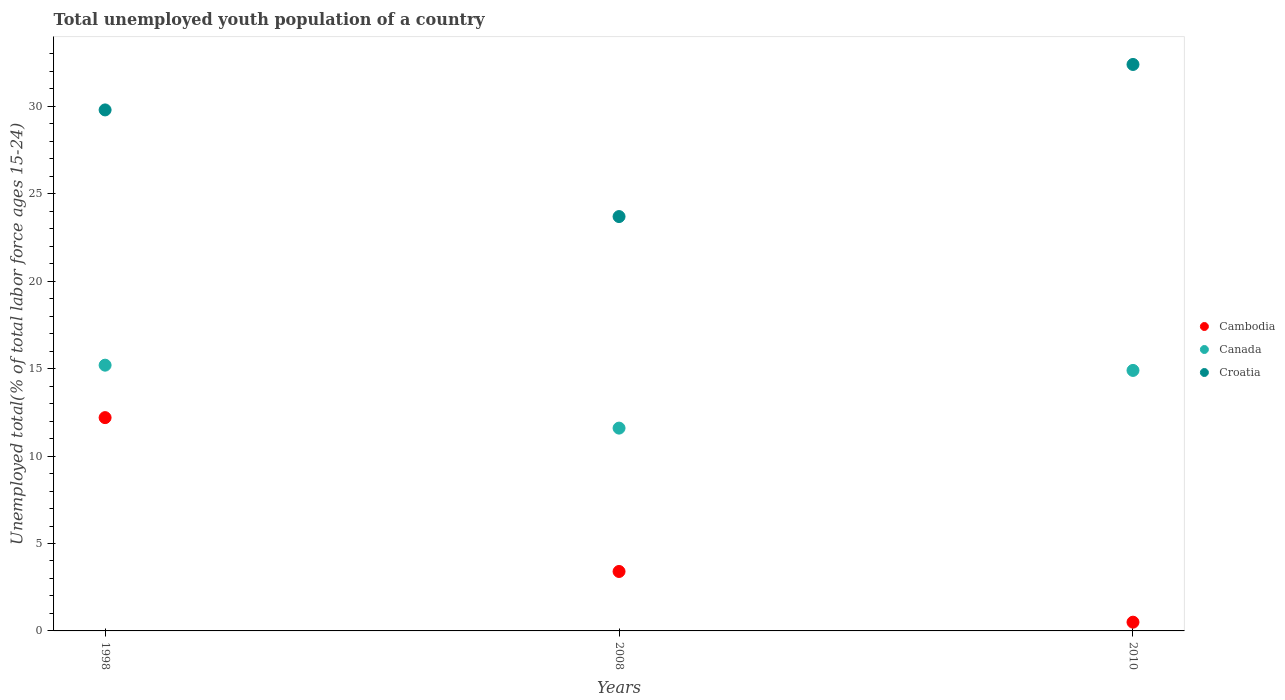Is the number of dotlines equal to the number of legend labels?
Provide a succinct answer. Yes. What is the percentage of total unemployed youth population of a country in Canada in 2008?
Keep it short and to the point. 11.6. Across all years, what is the maximum percentage of total unemployed youth population of a country in Cambodia?
Provide a short and direct response. 12.2. Across all years, what is the minimum percentage of total unemployed youth population of a country in Croatia?
Give a very brief answer. 23.7. What is the total percentage of total unemployed youth population of a country in Croatia in the graph?
Provide a succinct answer. 85.9. What is the difference between the percentage of total unemployed youth population of a country in Croatia in 1998 and that in 2008?
Your answer should be compact. 6.1. What is the difference between the percentage of total unemployed youth population of a country in Croatia in 1998 and the percentage of total unemployed youth population of a country in Cambodia in 2010?
Your response must be concise. 29.3. What is the average percentage of total unemployed youth population of a country in Cambodia per year?
Ensure brevity in your answer.  5.37. What is the ratio of the percentage of total unemployed youth population of a country in Croatia in 2008 to that in 2010?
Make the answer very short. 0.73. Is the percentage of total unemployed youth population of a country in Canada in 2008 less than that in 2010?
Your response must be concise. Yes. What is the difference between the highest and the second highest percentage of total unemployed youth population of a country in Canada?
Keep it short and to the point. 0.3. What is the difference between the highest and the lowest percentage of total unemployed youth population of a country in Cambodia?
Your answer should be compact. 11.7. Is the sum of the percentage of total unemployed youth population of a country in Croatia in 2008 and 2010 greater than the maximum percentage of total unemployed youth population of a country in Canada across all years?
Make the answer very short. Yes. Is it the case that in every year, the sum of the percentage of total unemployed youth population of a country in Canada and percentage of total unemployed youth population of a country in Cambodia  is greater than the percentage of total unemployed youth population of a country in Croatia?
Keep it short and to the point. No. Does the percentage of total unemployed youth population of a country in Cambodia monotonically increase over the years?
Offer a very short reply. No. Is the percentage of total unemployed youth population of a country in Cambodia strictly less than the percentage of total unemployed youth population of a country in Canada over the years?
Offer a terse response. Yes. How many dotlines are there?
Offer a terse response. 3. How many years are there in the graph?
Provide a short and direct response. 3. What is the difference between two consecutive major ticks on the Y-axis?
Ensure brevity in your answer.  5. Does the graph contain any zero values?
Offer a very short reply. No. What is the title of the graph?
Keep it short and to the point. Total unemployed youth population of a country. What is the label or title of the Y-axis?
Keep it short and to the point. Unemployed total(% of total labor force ages 15-24). What is the Unemployed total(% of total labor force ages 15-24) in Cambodia in 1998?
Ensure brevity in your answer.  12.2. What is the Unemployed total(% of total labor force ages 15-24) in Canada in 1998?
Your answer should be very brief. 15.2. What is the Unemployed total(% of total labor force ages 15-24) of Croatia in 1998?
Make the answer very short. 29.8. What is the Unemployed total(% of total labor force ages 15-24) in Cambodia in 2008?
Keep it short and to the point. 3.4. What is the Unemployed total(% of total labor force ages 15-24) of Canada in 2008?
Give a very brief answer. 11.6. What is the Unemployed total(% of total labor force ages 15-24) of Croatia in 2008?
Your answer should be compact. 23.7. What is the Unemployed total(% of total labor force ages 15-24) in Canada in 2010?
Give a very brief answer. 14.9. What is the Unemployed total(% of total labor force ages 15-24) in Croatia in 2010?
Your answer should be very brief. 32.4. Across all years, what is the maximum Unemployed total(% of total labor force ages 15-24) in Cambodia?
Give a very brief answer. 12.2. Across all years, what is the maximum Unemployed total(% of total labor force ages 15-24) of Canada?
Provide a succinct answer. 15.2. Across all years, what is the maximum Unemployed total(% of total labor force ages 15-24) in Croatia?
Provide a succinct answer. 32.4. Across all years, what is the minimum Unemployed total(% of total labor force ages 15-24) in Canada?
Your answer should be very brief. 11.6. Across all years, what is the minimum Unemployed total(% of total labor force ages 15-24) in Croatia?
Your answer should be compact. 23.7. What is the total Unemployed total(% of total labor force ages 15-24) in Cambodia in the graph?
Ensure brevity in your answer.  16.1. What is the total Unemployed total(% of total labor force ages 15-24) of Canada in the graph?
Ensure brevity in your answer.  41.7. What is the total Unemployed total(% of total labor force ages 15-24) in Croatia in the graph?
Offer a terse response. 85.9. What is the difference between the Unemployed total(% of total labor force ages 15-24) in Cambodia in 1998 and that in 2008?
Offer a terse response. 8.8. What is the difference between the Unemployed total(% of total labor force ages 15-24) in Canada in 1998 and that in 2008?
Your response must be concise. 3.6. What is the difference between the Unemployed total(% of total labor force ages 15-24) of Croatia in 1998 and that in 2008?
Keep it short and to the point. 6.1. What is the difference between the Unemployed total(% of total labor force ages 15-24) of Cambodia in 1998 and that in 2010?
Give a very brief answer. 11.7. What is the difference between the Unemployed total(% of total labor force ages 15-24) of Canada in 1998 and that in 2010?
Provide a succinct answer. 0.3. What is the difference between the Unemployed total(% of total labor force ages 15-24) of Canada in 2008 and that in 2010?
Your answer should be very brief. -3.3. What is the difference between the Unemployed total(% of total labor force ages 15-24) in Cambodia in 1998 and the Unemployed total(% of total labor force ages 15-24) in Croatia in 2008?
Give a very brief answer. -11.5. What is the difference between the Unemployed total(% of total labor force ages 15-24) of Cambodia in 1998 and the Unemployed total(% of total labor force ages 15-24) of Croatia in 2010?
Your response must be concise. -20.2. What is the difference between the Unemployed total(% of total labor force ages 15-24) in Canada in 1998 and the Unemployed total(% of total labor force ages 15-24) in Croatia in 2010?
Offer a terse response. -17.2. What is the difference between the Unemployed total(% of total labor force ages 15-24) in Canada in 2008 and the Unemployed total(% of total labor force ages 15-24) in Croatia in 2010?
Keep it short and to the point. -20.8. What is the average Unemployed total(% of total labor force ages 15-24) of Cambodia per year?
Give a very brief answer. 5.37. What is the average Unemployed total(% of total labor force ages 15-24) of Croatia per year?
Offer a very short reply. 28.63. In the year 1998, what is the difference between the Unemployed total(% of total labor force ages 15-24) in Cambodia and Unemployed total(% of total labor force ages 15-24) in Canada?
Ensure brevity in your answer.  -3. In the year 1998, what is the difference between the Unemployed total(% of total labor force ages 15-24) of Cambodia and Unemployed total(% of total labor force ages 15-24) of Croatia?
Provide a short and direct response. -17.6. In the year 1998, what is the difference between the Unemployed total(% of total labor force ages 15-24) in Canada and Unemployed total(% of total labor force ages 15-24) in Croatia?
Offer a very short reply. -14.6. In the year 2008, what is the difference between the Unemployed total(% of total labor force ages 15-24) of Cambodia and Unemployed total(% of total labor force ages 15-24) of Canada?
Offer a very short reply. -8.2. In the year 2008, what is the difference between the Unemployed total(% of total labor force ages 15-24) of Cambodia and Unemployed total(% of total labor force ages 15-24) of Croatia?
Offer a very short reply. -20.3. In the year 2010, what is the difference between the Unemployed total(% of total labor force ages 15-24) in Cambodia and Unemployed total(% of total labor force ages 15-24) in Canada?
Offer a terse response. -14.4. In the year 2010, what is the difference between the Unemployed total(% of total labor force ages 15-24) of Cambodia and Unemployed total(% of total labor force ages 15-24) of Croatia?
Your response must be concise. -31.9. In the year 2010, what is the difference between the Unemployed total(% of total labor force ages 15-24) in Canada and Unemployed total(% of total labor force ages 15-24) in Croatia?
Make the answer very short. -17.5. What is the ratio of the Unemployed total(% of total labor force ages 15-24) of Cambodia in 1998 to that in 2008?
Provide a succinct answer. 3.59. What is the ratio of the Unemployed total(% of total labor force ages 15-24) in Canada in 1998 to that in 2008?
Your answer should be very brief. 1.31. What is the ratio of the Unemployed total(% of total labor force ages 15-24) of Croatia in 1998 to that in 2008?
Your answer should be compact. 1.26. What is the ratio of the Unemployed total(% of total labor force ages 15-24) in Cambodia in 1998 to that in 2010?
Make the answer very short. 24.4. What is the ratio of the Unemployed total(% of total labor force ages 15-24) of Canada in 1998 to that in 2010?
Provide a short and direct response. 1.02. What is the ratio of the Unemployed total(% of total labor force ages 15-24) in Croatia in 1998 to that in 2010?
Provide a succinct answer. 0.92. What is the ratio of the Unemployed total(% of total labor force ages 15-24) of Cambodia in 2008 to that in 2010?
Keep it short and to the point. 6.8. What is the ratio of the Unemployed total(% of total labor force ages 15-24) of Canada in 2008 to that in 2010?
Ensure brevity in your answer.  0.78. What is the ratio of the Unemployed total(% of total labor force ages 15-24) of Croatia in 2008 to that in 2010?
Provide a short and direct response. 0.73. What is the difference between the highest and the lowest Unemployed total(% of total labor force ages 15-24) in Cambodia?
Your answer should be compact. 11.7. 